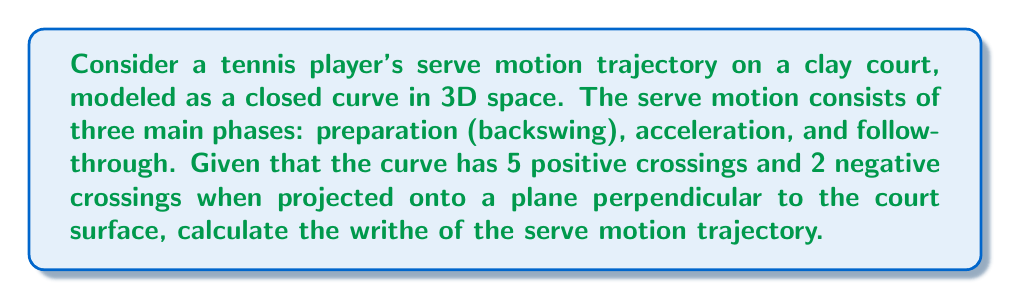What is the answer to this math problem? To calculate the writhe of the tennis player's serve motion trajectory, we'll follow these steps:

1) Recall the definition of writhe for a closed curve:
   The writhe is the sum of signed crossings in a regular projection of the curve.

2) In this case, we're given the projection onto a plane perpendicular to the clay court surface.

3) We have:
   - 5 positive crossings
   - 2 negative crossings

4) The writhe is calculated as:
   $$\text{Writhe} = \text{Number of positive crossings} - \text{Number of negative crossings}$$

5) Substituting our values:
   $$\text{Writhe} = 5 - 2 = 3$$

6) Therefore, the writhe of the serve motion trajectory is 3.

Note: The positive writhe suggests that the serve motion has a predominantly right-handed twist, which is common for right-handed players on clay courts where the slower surface often encourages more topspin serves.
Answer: 3 